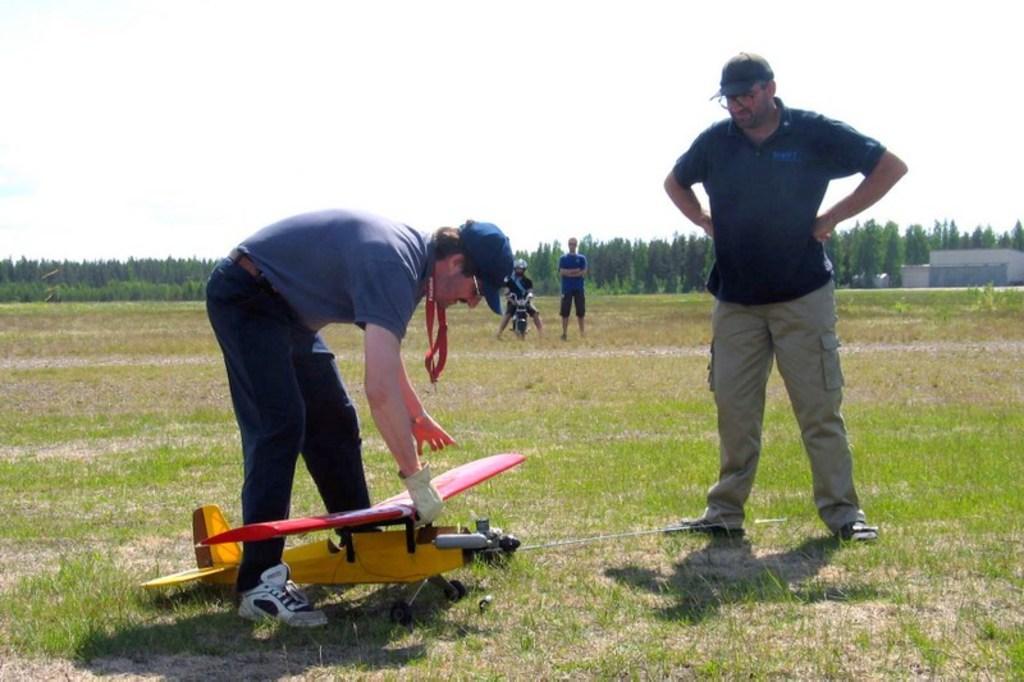In one or two sentences, can you explain what this image depicts? In this picture we can see a man wearing a blue color t-shirt and trying to fly the toy plane. Beside there is a man standing on the ground and looking to him. In the background we can see some trees. 